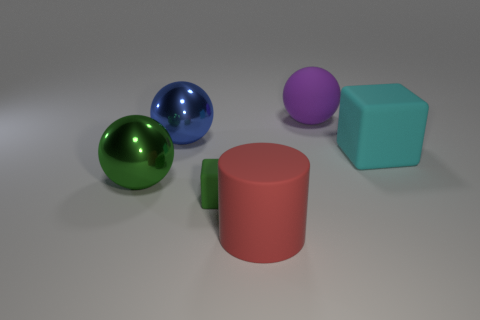Add 2 tiny green spheres. How many objects exist? 8 Subtract all cylinders. How many objects are left? 5 Subtract all large purple rubber objects. Subtract all big shiny objects. How many objects are left? 3 Add 6 tiny things. How many tiny things are left? 7 Add 3 tiny metallic cylinders. How many tiny metallic cylinders exist? 3 Subtract 0 cyan balls. How many objects are left? 6 